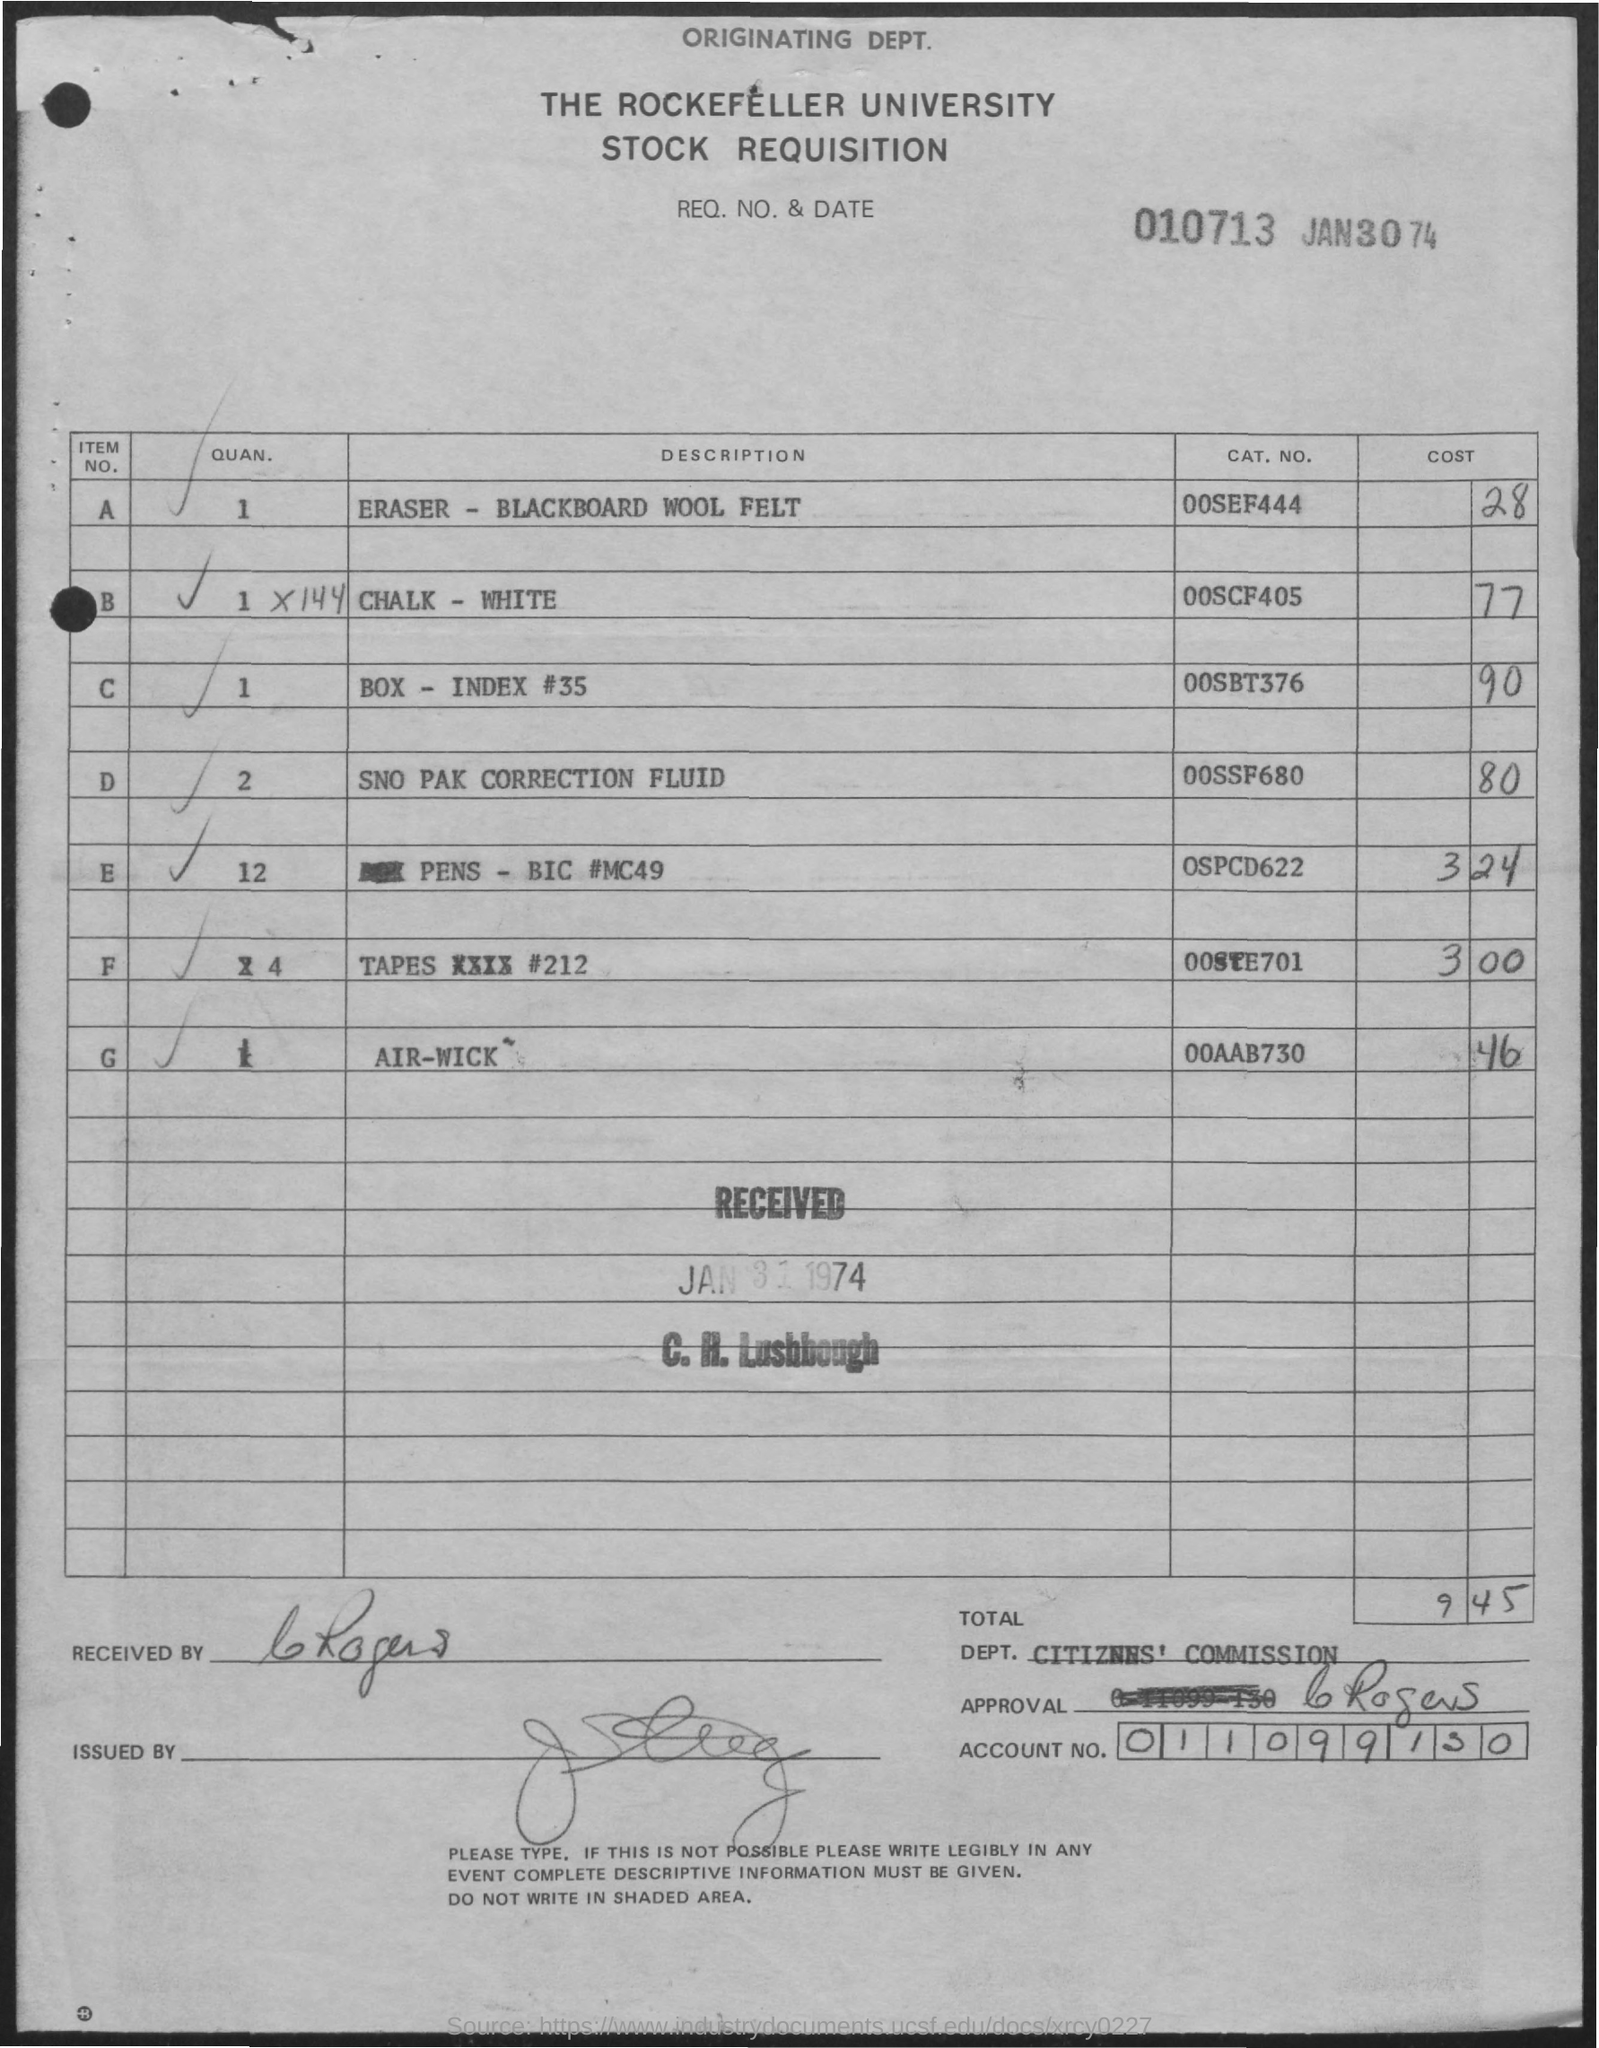Specify some key components in this picture. The document at the top mentions a date of JAN30 74. The Rockefeller University is a prominent university that is highly respected and well-known for its academic excellence and research contributions in various fields. The document was received by C. H. Lushbough. 